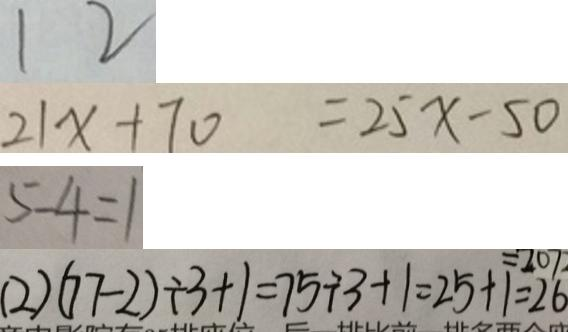<formula> <loc_0><loc_0><loc_500><loc_500>1 2 
 2 1 x + 7 0 = 2 5 x - 5 0 
 5 - 4 = 1 
 ( 2 ) ( 7 7 - 2 ) \div 3 + 1 = 7 5 \div 3 + 1 = 2 5 + 1 = 2 6</formula> 